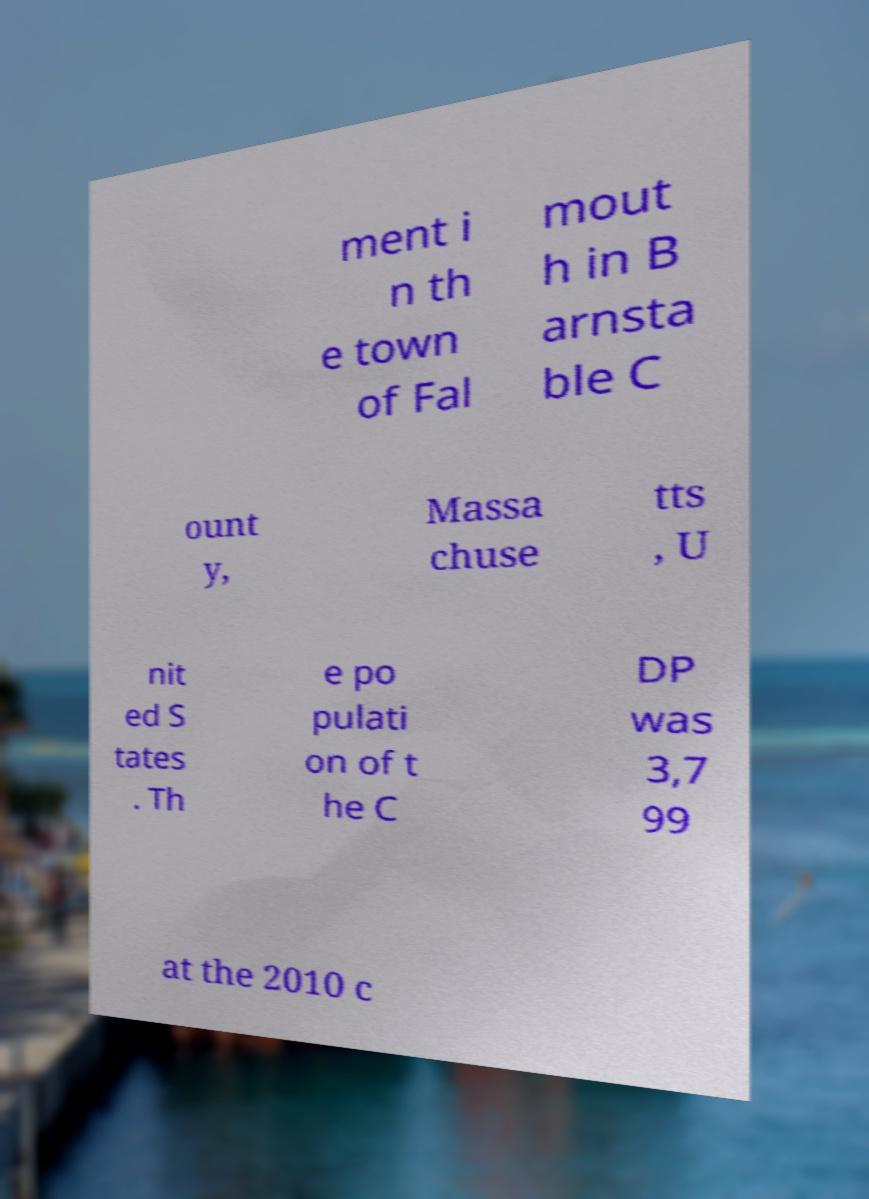Could you assist in decoding the text presented in this image and type it out clearly? ment i n th e town of Fal mout h in B arnsta ble C ount y, Massa chuse tts , U nit ed S tates . Th e po pulati on of t he C DP was 3,7 99 at the 2010 c 